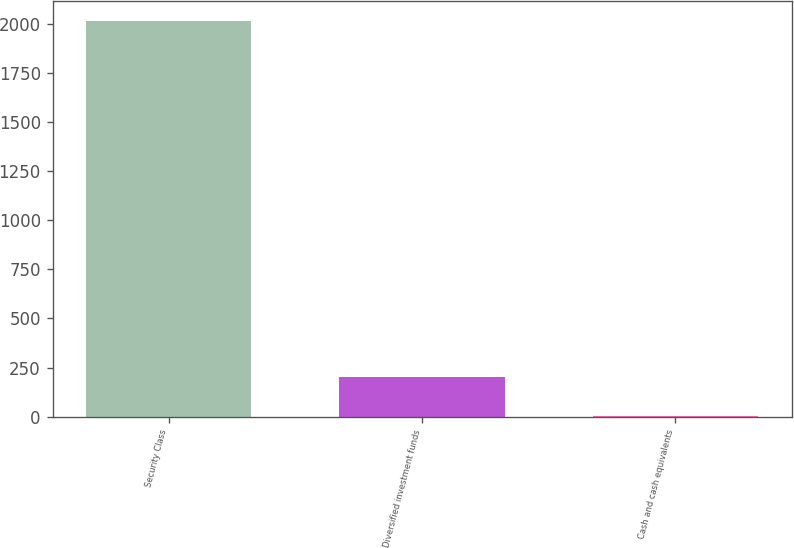<chart> <loc_0><loc_0><loc_500><loc_500><bar_chart><fcel>Security Class<fcel>Diversified investment funds<fcel>Cash and cash equivalents<nl><fcel>2016<fcel>204.12<fcel>2.8<nl></chart> 